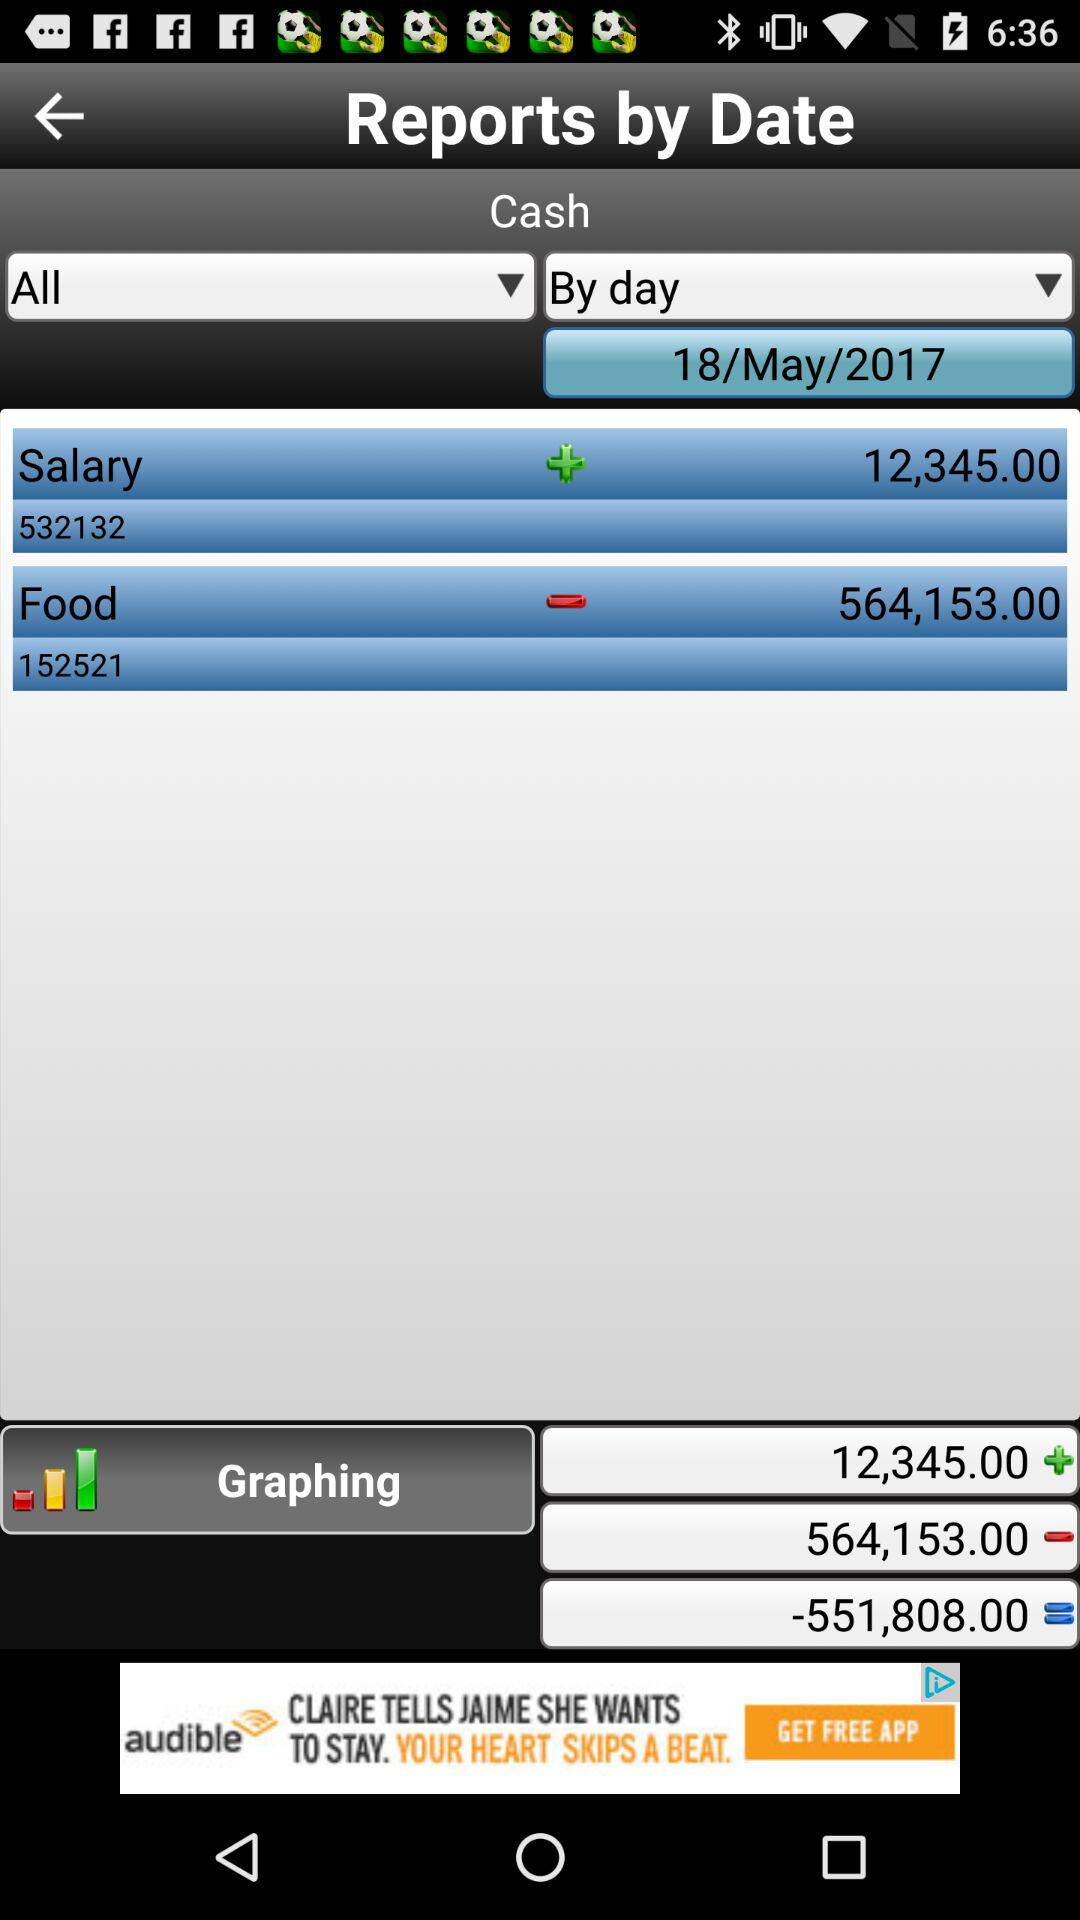What is the salary given on the screen? The given salary is 12,345.00. 